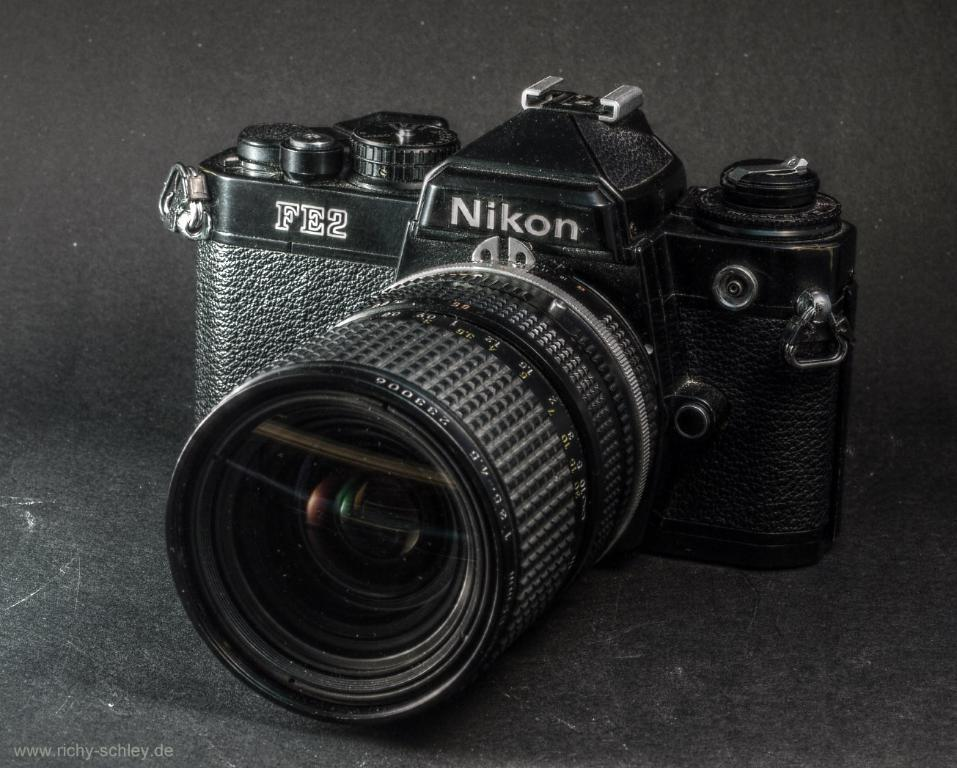What type of camera is visible in the image? There is a black color camera in the image. Can you describe any additional features or characteristics of the camera? The provided facts do not mention any additional features or characteristics of the camera. Is there any text or marking visible on the image? Yes, there is a watermark on the image. What type of sugar is being used to sweeten the worm in the image? There is no sugar or worm present in the image; it features a black color camera and a watermark. 